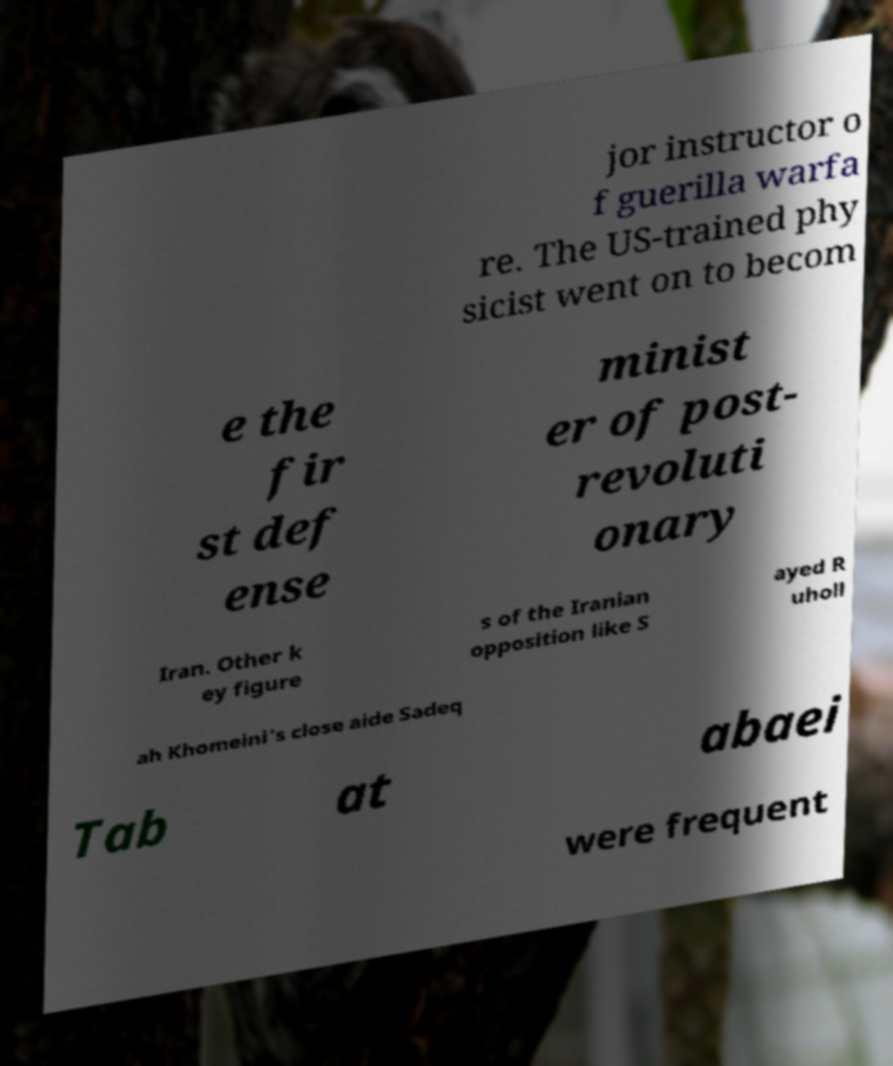Please identify and transcribe the text found in this image. jor instructor o f guerilla warfa re. The US-trained phy sicist went on to becom e the fir st def ense minist er of post- revoluti onary Iran. Other k ey figure s of the Iranian opposition like S ayed R uholl ah Khomeini's close aide Sadeq Tab at abaei were frequent 